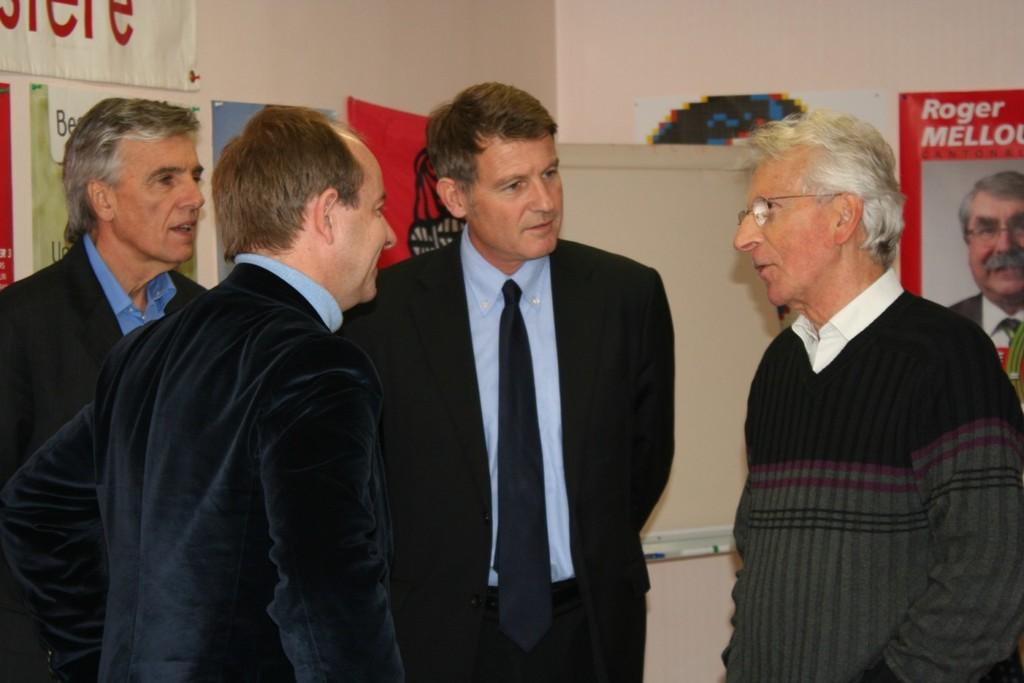How many men are present in the image? There are four men in the image. What are the men wearing that might provide warmth? Three of the men are wearing coats. Can you describe any accessories worn by the men? One of the men is wearing spectacles. What can be seen on the wall in the background of the image? There are posters on the wall in the background. What type of jellyfish can be seen hanging from the ceiling in the image? There are no jellyfish present in the image; it features four men and posters on the wall. Can you hear any bells ringing in the image? There is no auditory information provided in the image, so it is impossible to determine if any bells are ringing. 